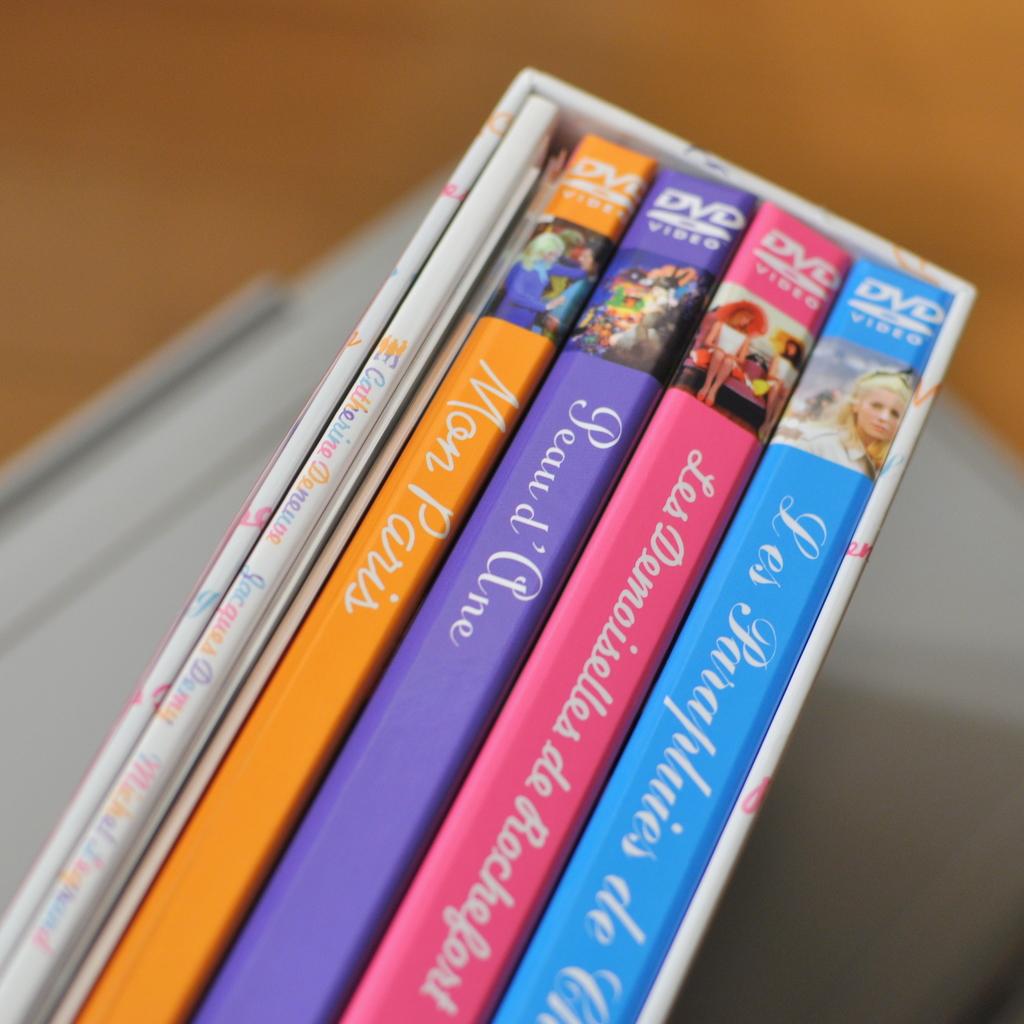What movie has the purple case?
Your response must be concise. Peau d'ane. What is the orange movie called?
Keep it short and to the point. Mon paris. 